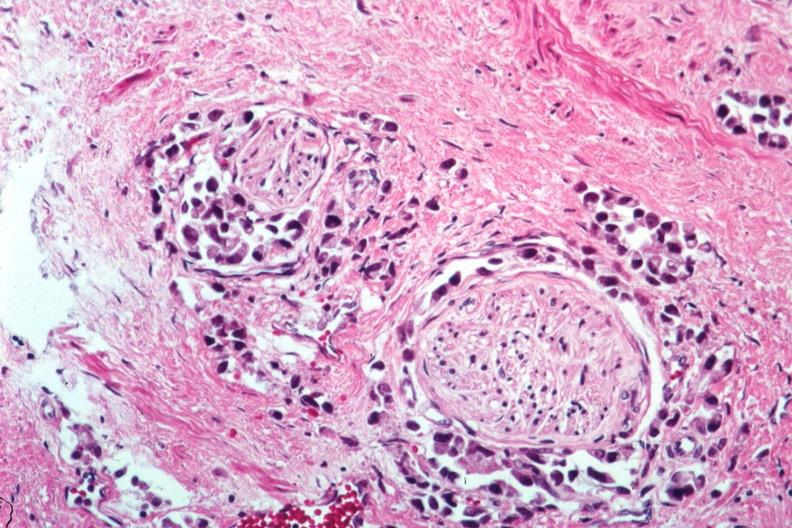does this image show perineural tumor invasion?
Answer the question using a single word or phrase. Yes 